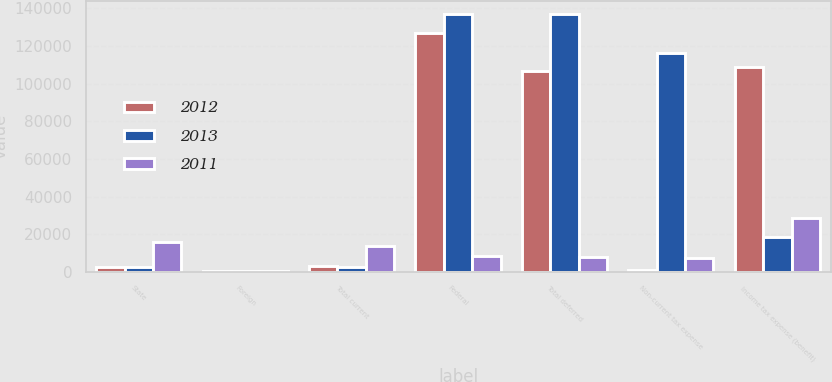<chart> <loc_0><loc_0><loc_500><loc_500><stacked_bar_chart><ecel><fcel>State<fcel>Foreign<fcel>Total current<fcel>Federal<fcel>Total deferred<fcel>Non-current tax expense<fcel>Income tax expense (benefit)<nl><fcel>2012<fcel>2677<fcel>382<fcel>3059<fcel>127040<fcel>106656<fcel>788<fcel>108927<nl><fcel>2013<fcel>2428<fcel>163<fcel>2591<fcel>136877<fcel>137076<fcel>116104<fcel>18381<nl><fcel>2011<fcel>15651<fcel>523<fcel>13529<fcel>8136<fcel>7895<fcel>7205<fcel>28629<nl></chart> 